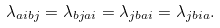Convert formula to latex. <formula><loc_0><loc_0><loc_500><loc_500>\lambda _ { a i b j } = \lambda _ { b j a i } = \lambda _ { j b a i } = \lambda _ { j b i a } .</formula> 